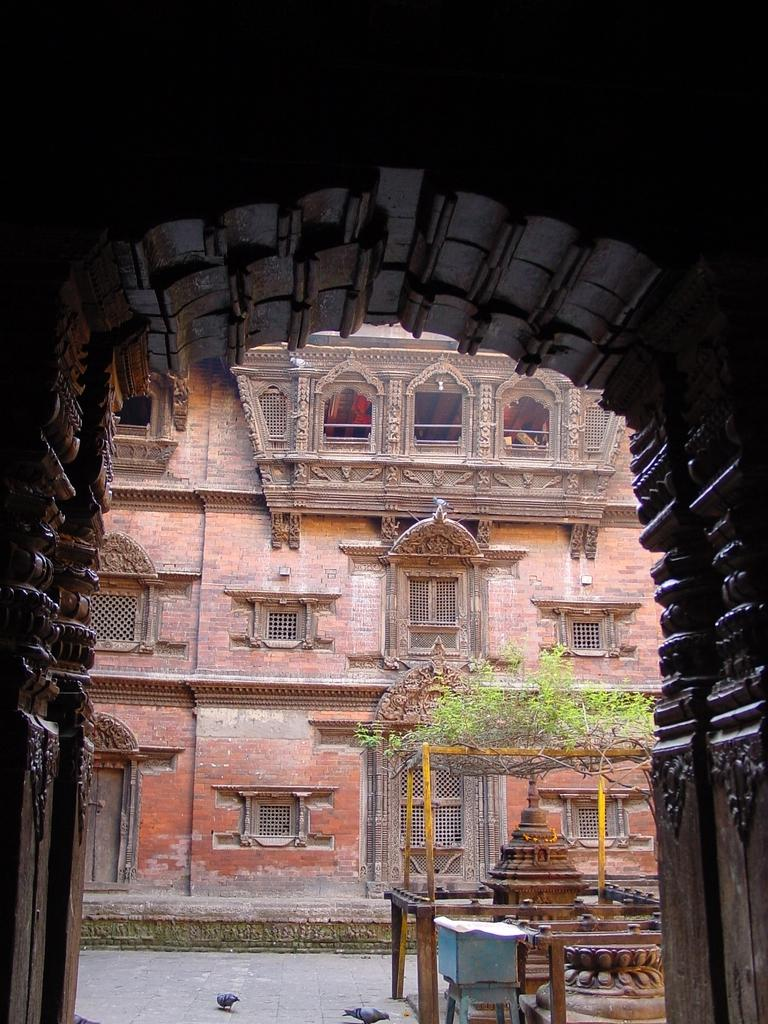What structure can be seen in the image? There is an arch in the image. What is located behind the arch? There are plants and a building behind the arch. Can you describe the architectural style of the structure behind the arch? There is an architecture behind the arch, but the specific style is not mentioned in the facts. How many birds are visible in the image? There are two birds in the image. What is on the floor in the image? There is an object on the floor in the image. What type of thrill can be experienced by the bells in the image? There are no bells present in the image, so it is not possible to determine if they can experience any thrill. What type of brass instrument is being played by the birds in the image? There are no brass instruments or birds playing instruments in the image. 